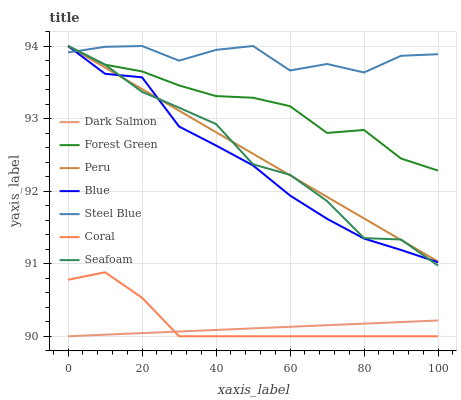Does Dark Salmon have the minimum area under the curve?
Answer yes or no. Yes. Does Steel Blue have the maximum area under the curve?
Answer yes or no. Yes. Does Seafoam have the minimum area under the curve?
Answer yes or no. No. Does Seafoam have the maximum area under the curve?
Answer yes or no. No. Is Peru the smoothest?
Answer yes or no. Yes. Is Steel Blue the roughest?
Answer yes or no. Yes. Is Seafoam the smoothest?
Answer yes or no. No. Is Seafoam the roughest?
Answer yes or no. No. Does Coral have the lowest value?
Answer yes or no. Yes. Does Seafoam have the lowest value?
Answer yes or no. No. Does Peru have the highest value?
Answer yes or no. Yes. Does Coral have the highest value?
Answer yes or no. No. Is Dark Salmon less than Steel Blue?
Answer yes or no. Yes. Is Peru greater than Coral?
Answer yes or no. Yes. Does Dark Salmon intersect Coral?
Answer yes or no. Yes. Is Dark Salmon less than Coral?
Answer yes or no. No. Is Dark Salmon greater than Coral?
Answer yes or no. No. Does Dark Salmon intersect Steel Blue?
Answer yes or no. No. 